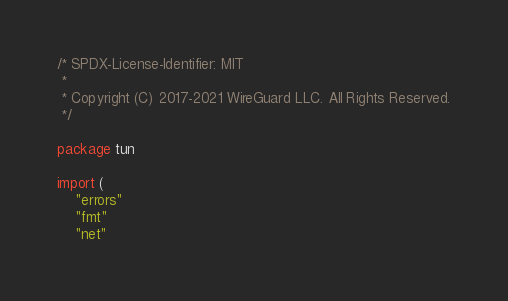<code> <loc_0><loc_0><loc_500><loc_500><_Go_>/* SPDX-License-Identifier: MIT
 *
 * Copyright (C) 2017-2021 WireGuard LLC. All Rights Reserved.
 */

package tun

import (
	"errors"
	"fmt"
	"net"</code> 